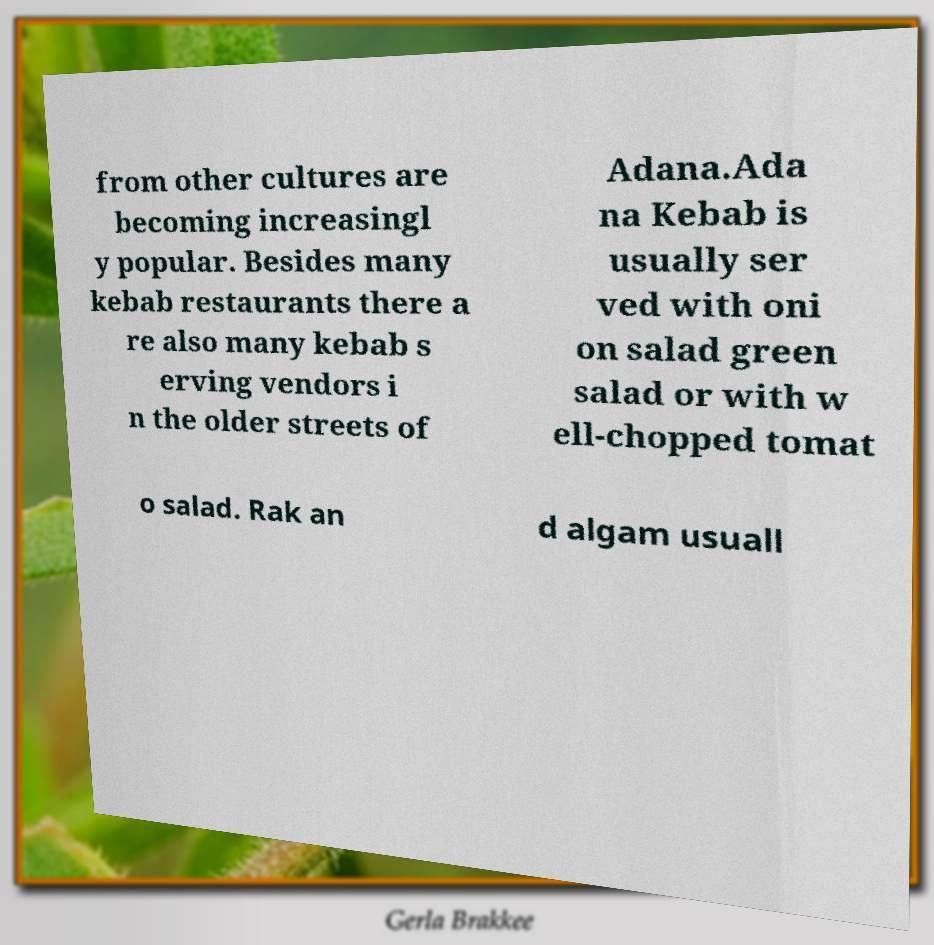Can you read and provide the text displayed in the image?This photo seems to have some interesting text. Can you extract and type it out for me? from other cultures are becoming increasingl y popular. Besides many kebab restaurants there a re also many kebab s erving vendors i n the older streets of Adana.Ada na Kebab is usually ser ved with oni on salad green salad or with w ell-chopped tomat o salad. Rak an d algam usuall 